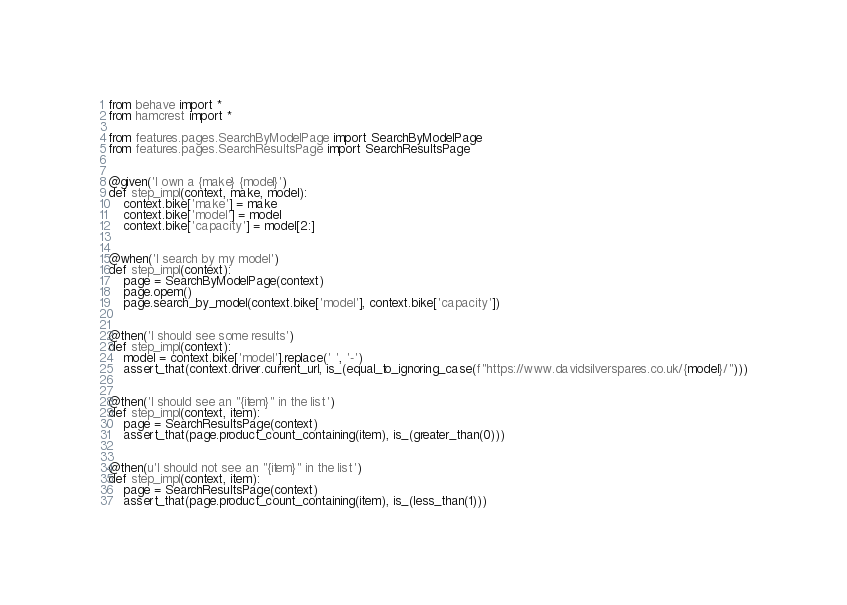<code> <loc_0><loc_0><loc_500><loc_500><_Python_>from behave import *
from hamcrest import *

from features.pages.SearchByModelPage import SearchByModelPage
from features.pages.SearchResultsPage import SearchResultsPage


@given('I own a {make} {model}')
def step_impl(context, make, model):
    context.bike['make'] = make
    context.bike['model'] = model
    context.bike['capacity'] = model[2:]


@when('I search by my model')
def step_impl(context):
    page = SearchByModelPage(context)
    page.opem()
    page.search_by_model(context.bike['model'], context.bike['capacity'])


@then('I should see some results')
def step_impl(context):
    model = context.bike['model'].replace(' ', '-')
    assert_that(context.driver.current_url, is_(equal_to_ignoring_case(f"https://www.davidsilverspares.co.uk/{model}/")))


@then('I should see an "{item}" in the list')
def step_impl(context, item):
    page = SearchResultsPage(context)
    assert_that(page.product_count_containing(item), is_(greater_than(0)))


@then(u'I should not see an "{item}" in the list')
def step_impl(context, item):
    page = SearchResultsPage(context)
    assert_that(page.product_count_containing(item), is_(less_than(1)))
</code> 